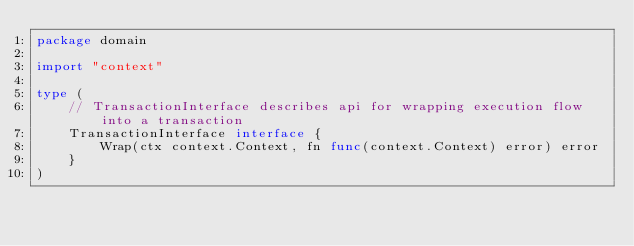Convert code to text. <code><loc_0><loc_0><loc_500><loc_500><_Go_>package domain

import "context"

type (
	// TransactionInterface describes api for wrapping execution flow into a transaction
	TransactionInterface interface {
		Wrap(ctx context.Context, fn func(context.Context) error) error
	}
)
</code> 